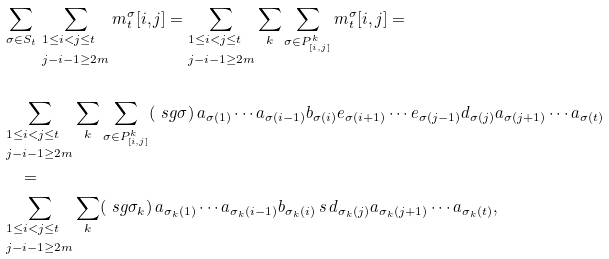<formula> <loc_0><loc_0><loc_500><loc_500>& \sum _ { \sigma \in S _ { t } } \, \sum _ { \begin{subarray} { 1 } 1 \leq i < j \leq t \\ \\ j - i - 1 \geq 2 m \end{subarray} } m _ { t } ^ { \sigma } [ i , j ] = \sum _ { \begin{subarray} { 1 } 1 \leq i < j \leq t \\ \\ j - i - 1 \geq 2 m \end{subarray} } \sum _ { k } \sum _ { \sigma \in P _ { [ i , j ] } ^ { k } } m _ { t } ^ { \sigma } [ i , j ] = \\ \\ & \sum _ { \begin{subarray} { 1 } 1 \leq i < j \leq t \\ \\ j - i - 1 \geq 2 m \end{subarray} } \sum _ { k } \sum _ { \sigma \in P _ { [ i , j ] } ^ { k } } ( \ s g \sigma ) \, a _ { \sigma ( 1 ) } \cdots a _ { \sigma ( i - 1 ) } b _ { \sigma ( i ) } e _ { \sigma ( i + 1 ) } \cdots e _ { \sigma ( j - 1 ) } d _ { \sigma ( j ) } a _ { \sigma ( j + 1 ) } \cdots a _ { \sigma ( t ) } \\ & \quad = \\ & \sum _ { \begin{subarray} { 1 } 1 \leq i < j \leq t \\ \\ j - i - 1 \geq 2 m \end{subarray} } \sum _ { k } ( \ s g \sigma _ { k } ) \, a _ { \sigma _ { k } ( 1 ) } \cdots a _ { \sigma _ { k } ( i - 1 ) } b _ { \sigma _ { k } ( i ) } \, s \, d _ { \sigma _ { k } ( j ) } a _ { \sigma _ { k } ( j + 1 ) } \cdots a _ { \sigma _ { k } ( t ) } ,</formula> 